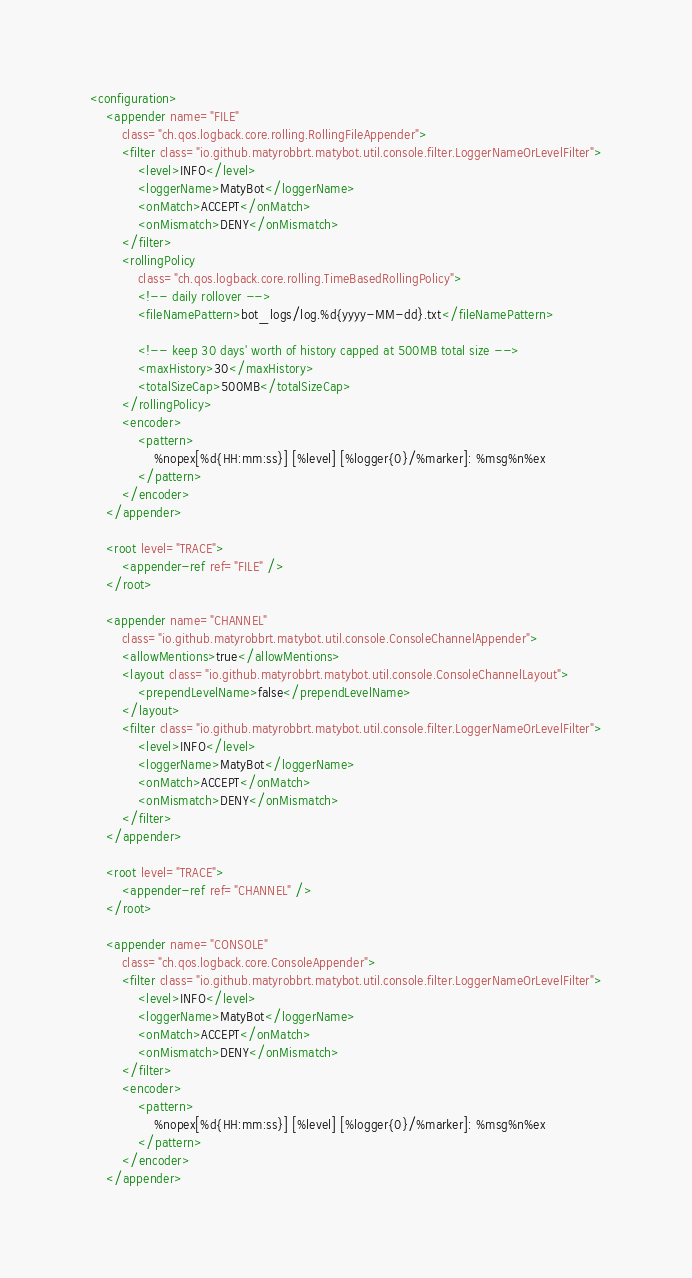<code> <loc_0><loc_0><loc_500><loc_500><_XML_><configuration>
    <appender name="FILE"
        class="ch.qos.logback.core.rolling.RollingFileAppender">
		<filter class="io.github.matyrobbrt.matybot.util.console.filter.LoggerNameOrLevelFilter">
			<level>INFO</level>
			<loggerName>MatyBot</loggerName>
			<onMatch>ACCEPT</onMatch>
			<onMismatch>DENY</onMismatch>
		</filter>
        <rollingPolicy
            class="ch.qos.logback.core.rolling.TimeBasedRollingPolicy">
            <!-- daily rollover -->
            <fileNamePattern>bot_logs/log.%d{yyyy-MM-dd}.txt</fileNamePattern>

            <!-- keep 30 days' worth of history capped at 500MB total size -->
            <maxHistory>30</maxHistory>
            <totalSizeCap>500MB</totalSizeCap>
        </rollingPolicy>
        <encoder>
            <pattern>
                %nopex[%d{HH:mm:ss}] [%level] [%logger{0}/%marker]: %msg%n%ex
            </pattern>
        </encoder>
    </appender>
	
	<root level="TRACE">
        <appender-ref ref="FILE" />
    </root>
	
	<appender name="CHANNEL"
        class="io.github.matyrobbrt.matybot.util.console.ConsoleChannelAppender">
        <allowMentions>true</allowMentions>
        <layout class="io.github.matyrobbrt.matybot.util.console.ConsoleChannelLayout">
            <prependLevelName>false</prependLevelName>
        </layout>
		<filter class="io.github.matyrobbrt.matybot.util.console.filter.LoggerNameOrLevelFilter">
			<level>INFO</level>
			<loggerName>MatyBot</loggerName>
			<onMatch>ACCEPT</onMatch>
			<onMismatch>DENY</onMismatch>
		</filter>
    </appender>
	
	<root level="TRACE">
        <appender-ref ref="CHANNEL" />
    </root>
	
	<appender name="CONSOLE"
        class="ch.qos.logback.core.ConsoleAppender">
		<filter class="io.github.matyrobbrt.matybot.util.console.filter.LoggerNameOrLevelFilter">
			<level>INFO</level>
			<loggerName>MatyBot</loggerName>
			<onMatch>ACCEPT</onMatch>
			<onMismatch>DENY</onMismatch>
		</filter>
		<encoder>
            <pattern>
                %nopex[%d{HH:mm:ss}] [%level] [%logger{0}/%marker]: %msg%n%ex
            </pattern>
        </encoder>
    </appender></code> 